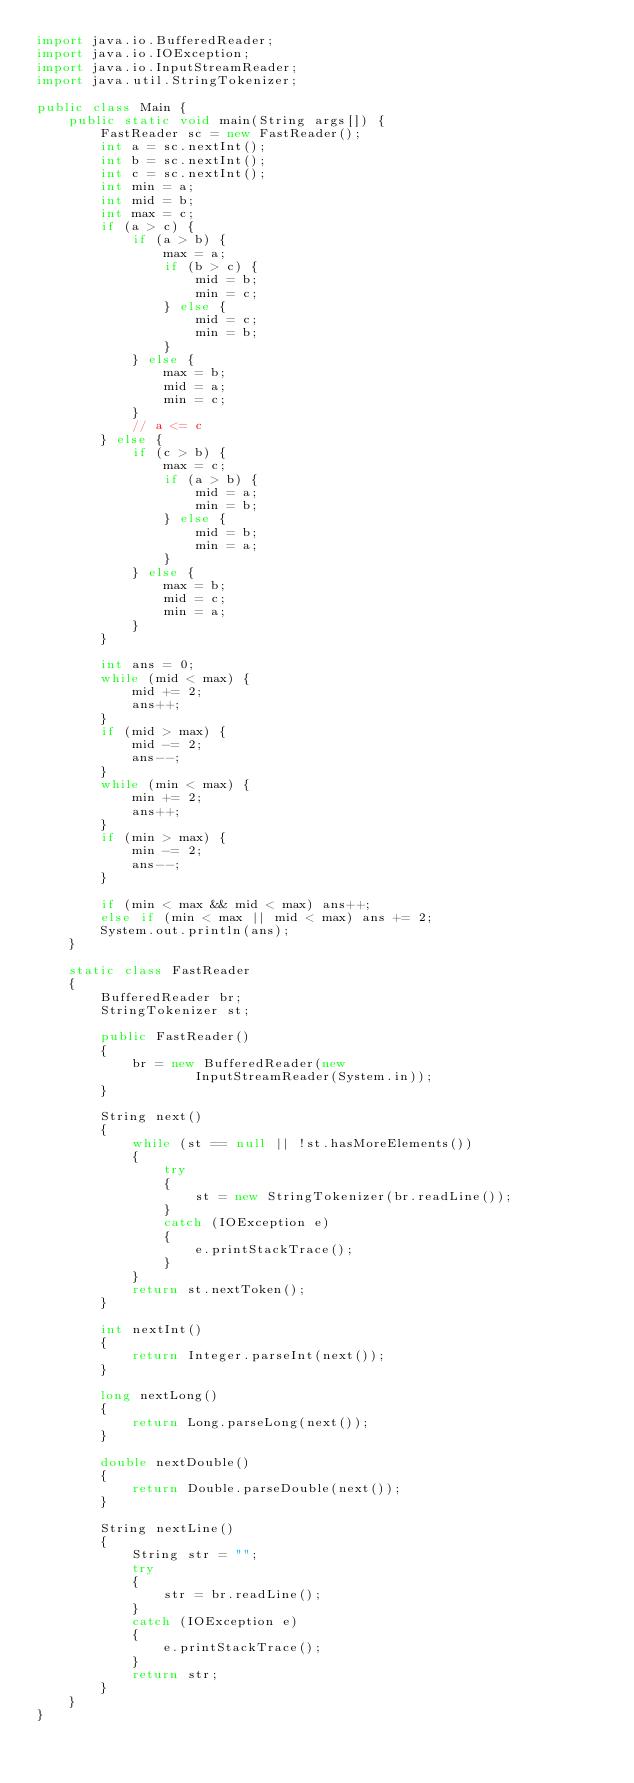Convert code to text. <code><loc_0><loc_0><loc_500><loc_500><_Java_>import java.io.BufferedReader;
import java.io.IOException;
import java.io.InputStreamReader;
import java.util.StringTokenizer;

public class Main {
    public static void main(String args[]) {
        FastReader sc = new FastReader();
        int a = sc.nextInt();
        int b = sc.nextInt();
        int c = sc.nextInt();
        int min = a;
        int mid = b;
        int max = c;
        if (a > c) {
            if (a > b) {
                max = a;
                if (b > c) {
                    mid = b;
                    min = c;
                } else {
                    mid = c;
                    min = b;
                }
            } else {
                max = b;
                mid = a;
                min = c;
            }
            // a <= c
        } else {
            if (c > b) {
                max = c;
                if (a > b) {
                    mid = a;
                    min = b;
                } else {
                    mid = b;
                    min = a;
                }
            } else {
                max = b;
                mid = c;
                min = a;
            }
        }

        int ans = 0;
        while (mid < max) {
            mid += 2;
            ans++;
        }
        if (mid > max) {
            mid -= 2;
            ans--;
        }
        while (min < max) {
            min += 2;
            ans++;
        }
        if (min > max) {
            min -= 2;
            ans--;
        }

        if (min < max && mid < max) ans++;
        else if (min < max || mid < max) ans += 2;
        System.out.println(ans);
    }

    static class FastReader
    {
        BufferedReader br;
        StringTokenizer st;

        public FastReader()
        {
            br = new BufferedReader(new
                    InputStreamReader(System.in));
        }

        String next()
        {
            while (st == null || !st.hasMoreElements())
            {
                try
                {
                    st = new StringTokenizer(br.readLine());
                }
                catch (IOException e)
                {
                    e.printStackTrace();
                }
            }
            return st.nextToken();
        }

        int nextInt()
        {
            return Integer.parseInt(next());
        }

        long nextLong()
        {
            return Long.parseLong(next());
        }

        double nextDouble()
        {
            return Double.parseDouble(next());
        }

        String nextLine()
        {
            String str = "";
            try
            {
                str = br.readLine();
            }
            catch (IOException e)
            {
                e.printStackTrace();
            }
            return str;
        }
    }
}
</code> 